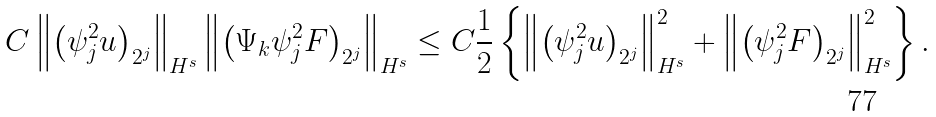<formula> <loc_0><loc_0><loc_500><loc_500>C \left \| \left ( \psi _ { j } ^ { 2 } u \right ) _ { 2 ^ { j } } \right \| _ { H ^ { s } } \left \| \left ( \Psi _ { k } \psi _ { j } ^ { 2 } F \right ) _ { 2 ^ { j } } \right \| _ { H ^ { s } } \leq C \frac { 1 } { 2 } \left \{ \left \| \left ( \psi _ { j } ^ { 2 } u \right ) _ { 2 ^ { j } } \right \| _ { H ^ { s } } ^ { 2 } + \left \| \left ( \psi _ { j } ^ { 2 } F \right ) _ { 2 ^ { j } } \right \| _ { H ^ { s } } ^ { 2 } \right \} .</formula> 